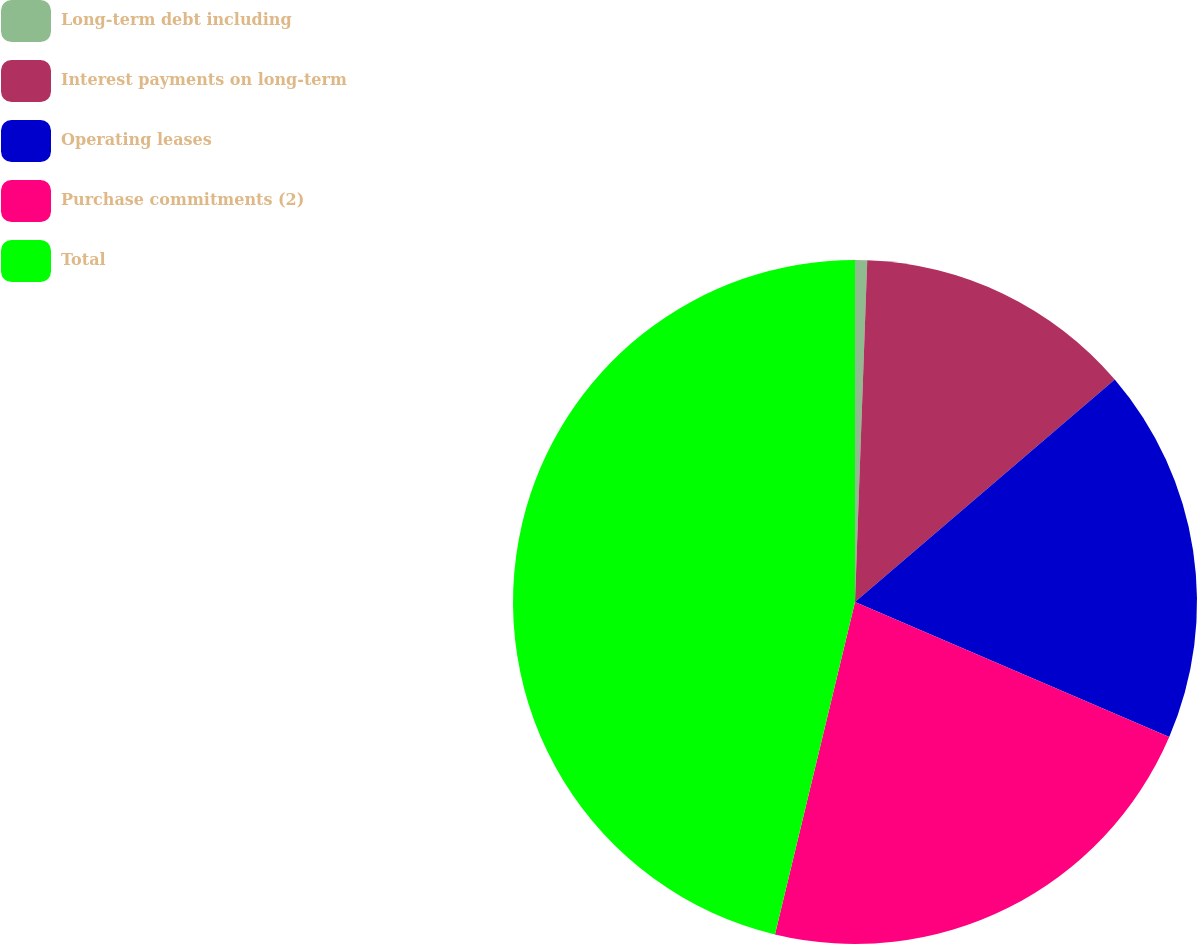Convert chart. <chart><loc_0><loc_0><loc_500><loc_500><pie_chart><fcel>Long-term debt including<fcel>Interest payments on long-term<fcel>Operating leases<fcel>Purchase commitments (2)<fcel>Total<nl><fcel>0.57%<fcel>13.16%<fcel>17.73%<fcel>22.3%<fcel>46.24%<nl></chart> 